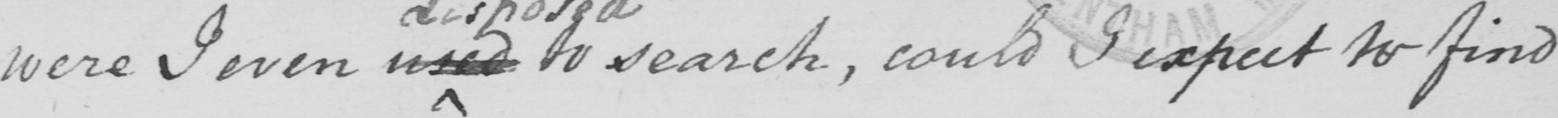Can you tell me what this handwritten text says? were I even used to search , could I expect to find 